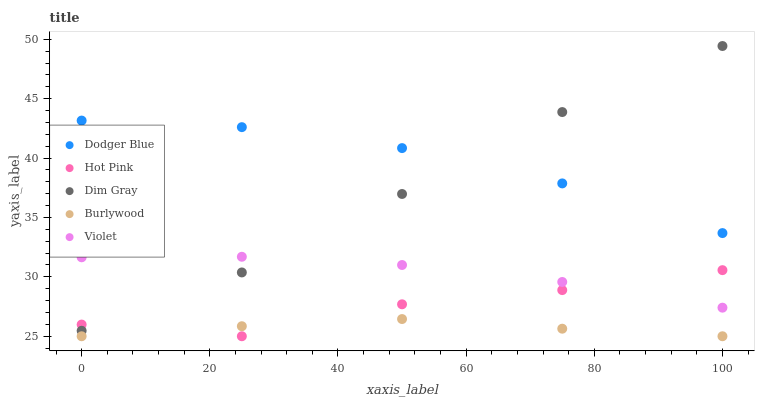Does Burlywood have the minimum area under the curve?
Answer yes or no. Yes. Does Dodger Blue have the maximum area under the curve?
Answer yes or no. Yes. Does Dim Gray have the minimum area under the curve?
Answer yes or no. No. Does Dim Gray have the maximum area under the curve?
Answer yes or no. No. Is Burlywood the smoothest?
Answer yes or no. Yes. Is Hot Pink the roughest?
Answer yes or no. Yes. Is Dim Gray the smoothest?
Answer yes or no. No. Is Dim Gray the roughest?
Answer yes or no. No. Does Burlywood have the lowest value?
Answer yes or no. Yes. Does Dim Gray have the lowest value?
Answer yes or no. No. Does Dim Gray have the highest value?
Answer yes or no. Yes. Does Hot Pink have the highest value?
Answer yes or no. No. Is Violet less than Dodger Blue?
Answer yes or no. Yes. Is Violet greater than Burlywood?
Answer yes or no. Yes. Does Dim Gray intersect Violet?
Answer yes or no. Yes. Is Dim Gray less than Violet?
Answer yes or no. No. Is Dim Gray greater than Violet?
Answer yes or no. No. Does Violet intersect Dodger Blue?
Answer yes or no. No. 